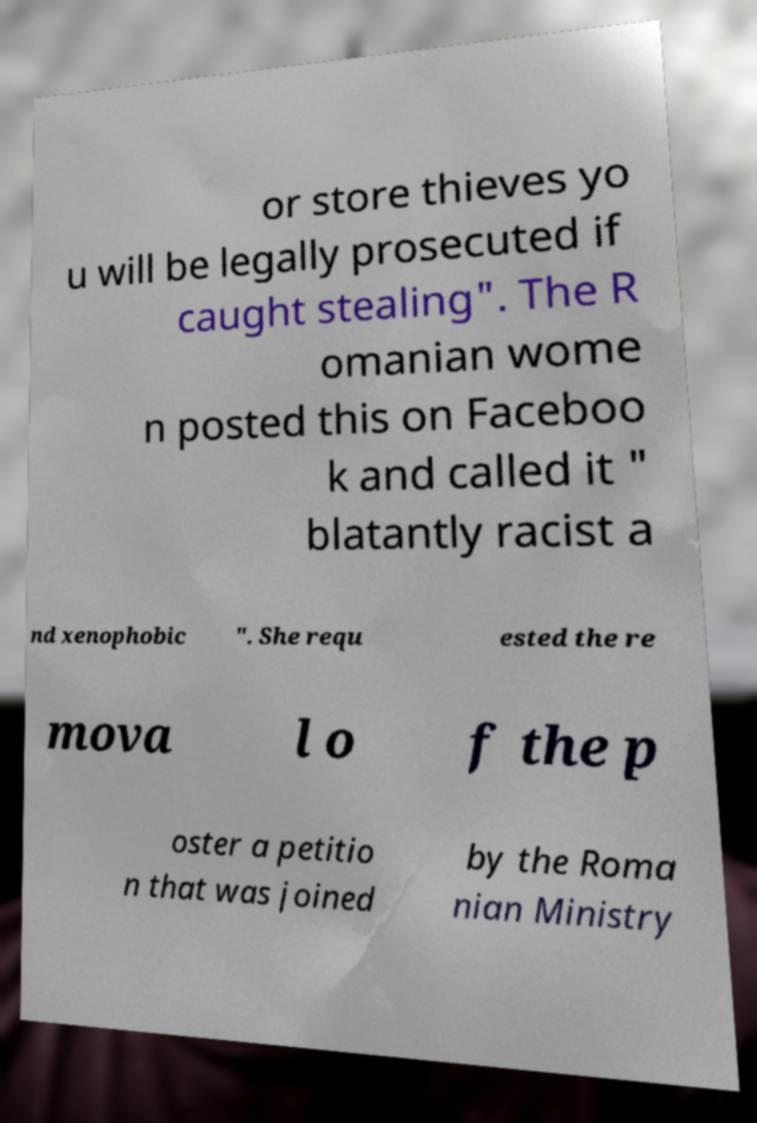For documentation purposes, I need the text within this image transcribed. Could you provide that? or store thieves yo u will be legally prosecuted if caught stealing". The R omanian wome n posted this on Faceboo k and called it " blatantly racist a nd xenophobic ". She requ ested the re mova l o f the p oster a petitio n that was joined by the Roma nian Ministry 